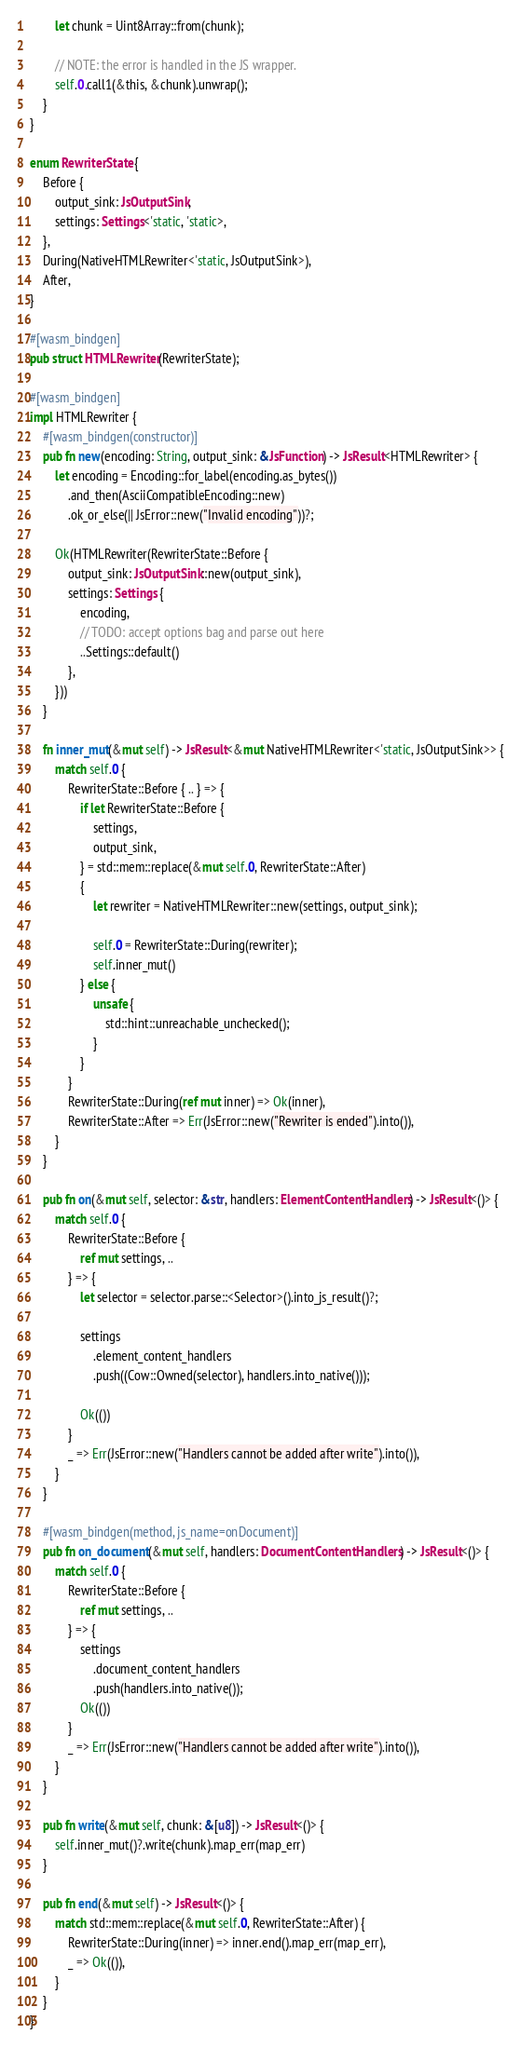<code> <loc_0><loc_0><loc_500><loc_500><_Rust_>        let chunk = Uint8Array::from(chunk);

        // NOTE: the error is handled in the JS wrapper.
        self.0.call1(&this, &chunk).unwrap();
    }
}

enum RewriterState {
    Before {
        output_sink: JsOutputSink,
        settings: Settings<'static, 'static>,
    },
    During(NativeHTMLRewriter<'static, JsOutputSink>),
    After,
}

#[wasm_bindgen]
pub struct HTMLRewriter(RewriterState);

#[wasm_bindgen]
impl HTMLRewriter {
    #[wasm_bindgen(constructor)]
    pub fn new(encoding: String, output_sink: &JsFunction) -> JsResult<HTMLRewriter> {
        let encoding = Encoding::for_label(encoding.as_bytes())
            .and_then(AsciiCompatibleEncoding::new)
            .ok_or_else(|| JsError::new("Invalid encoding"))?;

        Ok(HTMLRewriter(RewriterState::Before {
            output_sink: JsOutputSink::new(output_sink),
            settings: Settings {
                encoding,
                // TODO: accept options bag and parse out here
                ..Settings::default()
            },
        }))
    }

    fn inner_mut(&mut self) -> JsResult<&mut NativeHTMLRewriter<'static, JsOutputSink>> {
        match self.0 {
            RewriterState::Before { .. } => {
                if let RewriterState::Before {
                    settings,
                    output_sink,
                } = std::mem::replace(&mut self.0, RewriterState::After)
                {
                    let rewriter = NativeHTMLRewriter::new(settings, output_sink);

                    self.0 = RewriterState::During(rewriter);
                    self.inner_mut()
                } else {
                    unsafe {
                        std::hint::unreachable_unchecked();
                    }
                }
            }
            RewriterState::During(ref mut inner) => Ok(inner),
            RewriterState::After => Err(JsError::new("Rewriter is ended").into()),
        }
    }

    pub fn on(&mut self, selector: &str, handlers: ElementContentHandlers) -> JsResult<()> {
        match self.0 {
            RewriterState::Before {
                ref mut settings, ..
            } => {
                let selector = selector.parse::<Selector>().into_js_result()?;

                settings
                    .element_content_handlers
                    .push((Cow::Owned(selector), handlers.into_native()));

                Ok(())
            }
            _ => Err(JsError::new("Handlers cannot be added after write").into()),
        }
    }

    #[wasm_bindgen(method, js_name=onDocument)]
    pub fn on_document(&mut self, handlers: DocumentContentHandlers) -> JsResult<()> {
        match self.0 {
            RewriterState::Before {
                ref mut settings, ..
            } => {
                settings
                    .document_content_handlers
                    .push(handlers.into_native());
                Ok(())
            }
            _ => Err(JsError::new("Handlers cannot be added after write").into()),
        }
    }

    pub fn write(&mut self, chunk: &[u8]) -> JsResult<()> {
        self.inner_mut()?.write(chunk).map_err(map_err)
    }

    pub fn end(&mut self) -> JsResult<()> {
        match std::mem::replace(&mut self.0, RewriterState::After) {
            RewriterState::During(inner) => inner.end().map_err(map_err),
            _ => Ok(()),
        }
    }
}
</code> 